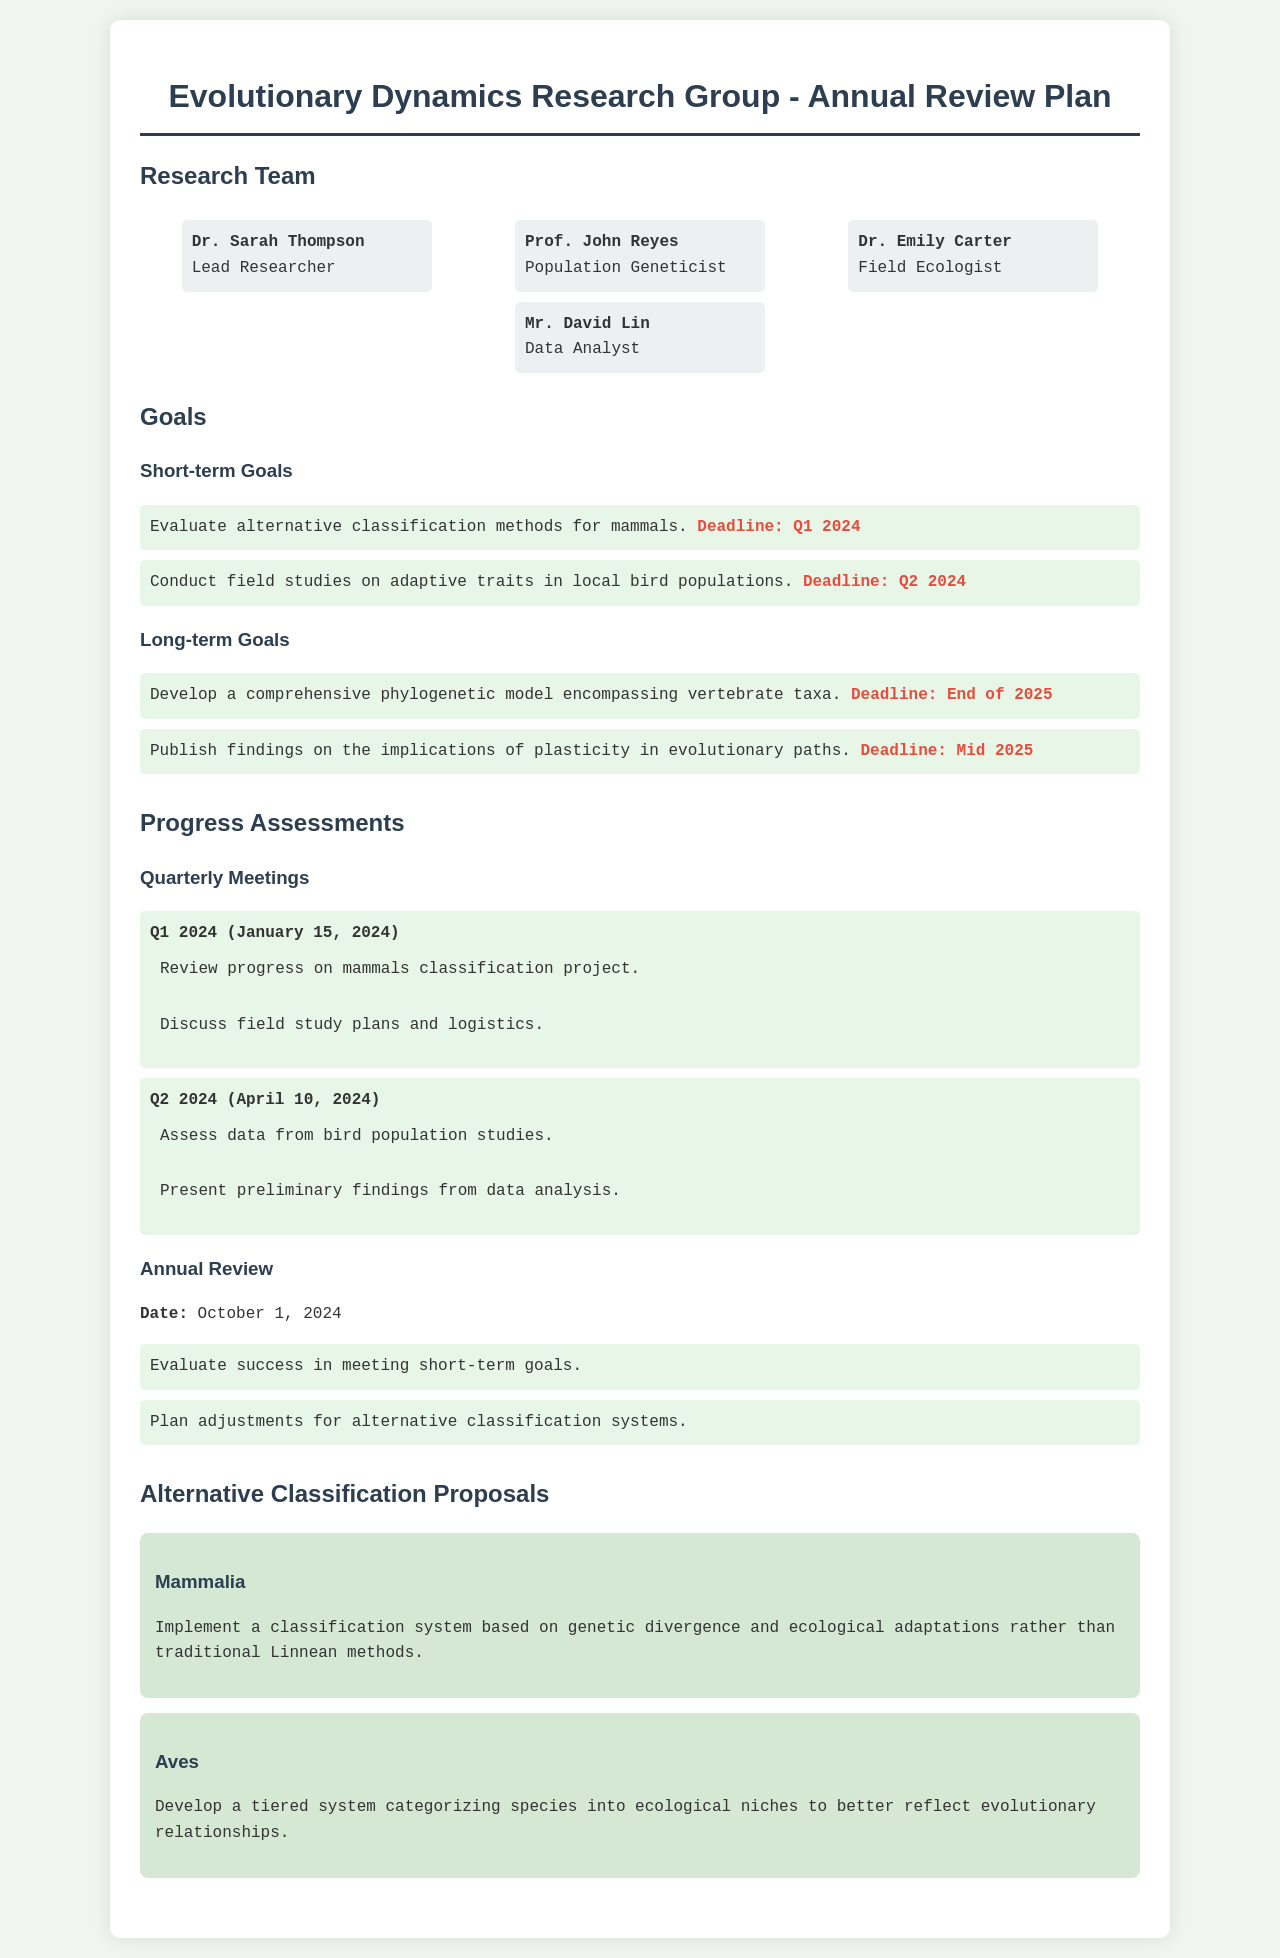What is the name of the lead researcher? The name is mentioned in the section listing team members.
Answer: Dr. Sarah Thompson What is the deadline for evaluating alternative classification methods for mammals? The deadline is specified under the short-term goals in the document.
Answer: Q1 2024 How many short-term goals are listed in the document? The total number of short-term goals can be counted from the section where they are listed.
Answer: 2 What is the date of the annual review? The date is clearly stated in the progress assessments section.
Answer: October 1, 2024 Which species does the proposal focus on for a tiered classification system? The species is indicated in the section about alternative classification proposals.
Answer: Aves What will be discussed in the Q2 2024 meeting? The meeting agenda includes items listed under the quarterly meetings.
Answer: Assess data from bird population studies What is the end date for the long-term goals? The end date can be found under the long-term goals section in the document.
Answer: End of 2025 How many team members are listed? The document lists each member in the team members section.
Answer: 4 What is the proposed basis for the classification system of Mammalia? The basis is detailed in the alternative classification proposals section.
Answer: Genetic divergence and ecological adaptations 